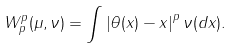Convert formula to latex. <formula><loc_0><loc_0><loc_500><loc_500>W _ { p } ^ { p } ( \mu , \nu ) = \int \left | \theta ( x ) - x \right | ^ { p } \nu ( d x ) .</formula> 